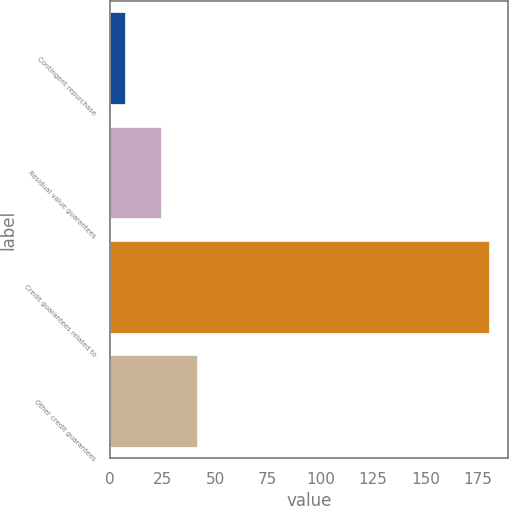<chart> <loc_0><loc_0><loc_500><loc_500><bar_chart><fcel>Contingent repurchase<fcel>Residual value guarantees<fcel>Credit guarantees related to<fcel>Other credit guarantees<nl><fcel>7<fcel>24.3<fcel>180<fcel>41.6<nl></chart> 